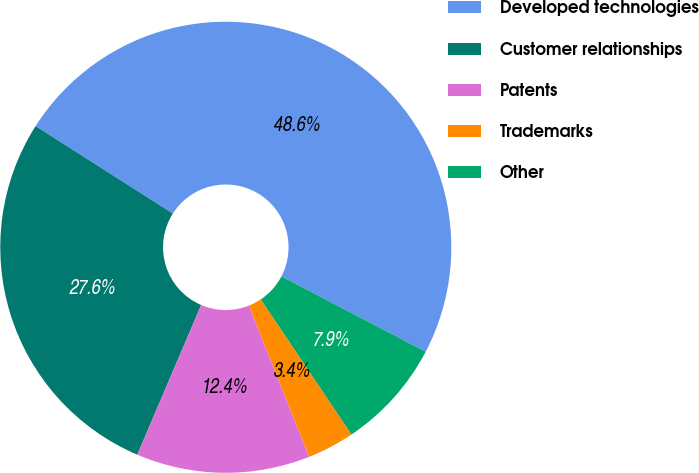Convert chart. <chart><loc_0><loc_0><loc_500><loc_500><pie_chart><fcel>Developed technologies<fcel>Customer relationships<fcel>Patents<fcel>Trademarks<fcel>Other<nl><fcel>48.64%<fcel>27.61%<fcel>12.44%<fcel>3.39%<fcel>7.92%<nl></chart> 